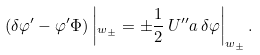<formula> <loc_0><loc_0><loc_500><loc_500>( \delta \varphi ^ { \prime } - \varphi ^ { \prime } \Phi ) \left | _ { w _ { \pm } } = \pm \frac { 1 } { 2 } \, U ^ { \prime \prime } a \, \delta \varphi \right | _ { w _ { \pm } } .</formula> 